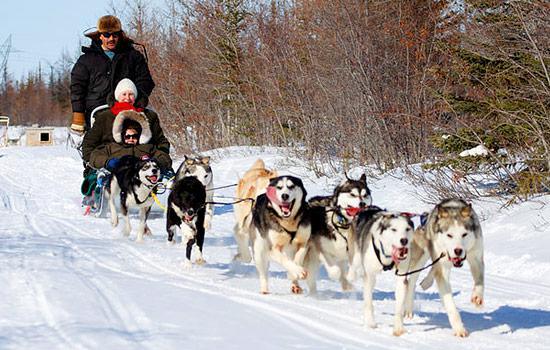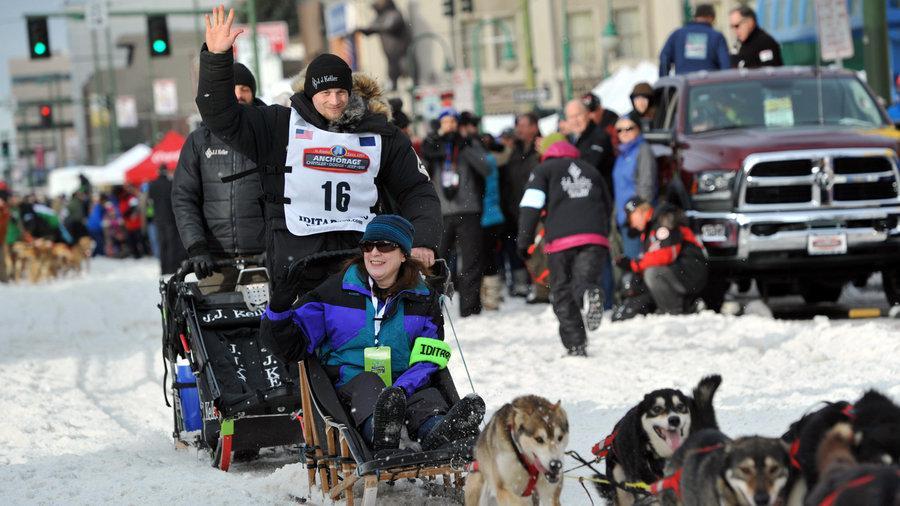The first image is the image on the left, the second image is the image on the right. Analyze the images presented: Is the assertion "One image shows a team of dogs in matching bright-colored booties moving leftward in front of people lining the street." valid? Answer yes or no. No. The first image is the image on the left, the second image is the image on the right. Examine the images to the left and right. Is the description "A person riding the sled is waving." accurate? Answer yes or no. Yes. 